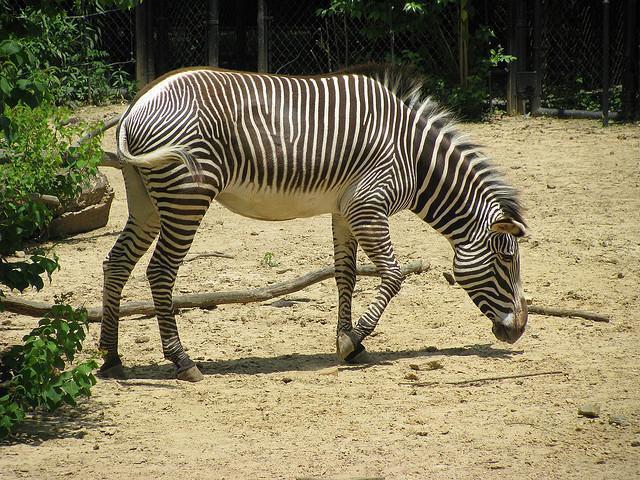How many tails can you see?
Give a very brief answer. 1. How many zebras are in the picture?
Give a very brief answer. 1. How many people are there?
Give a very brief answer. 0. 